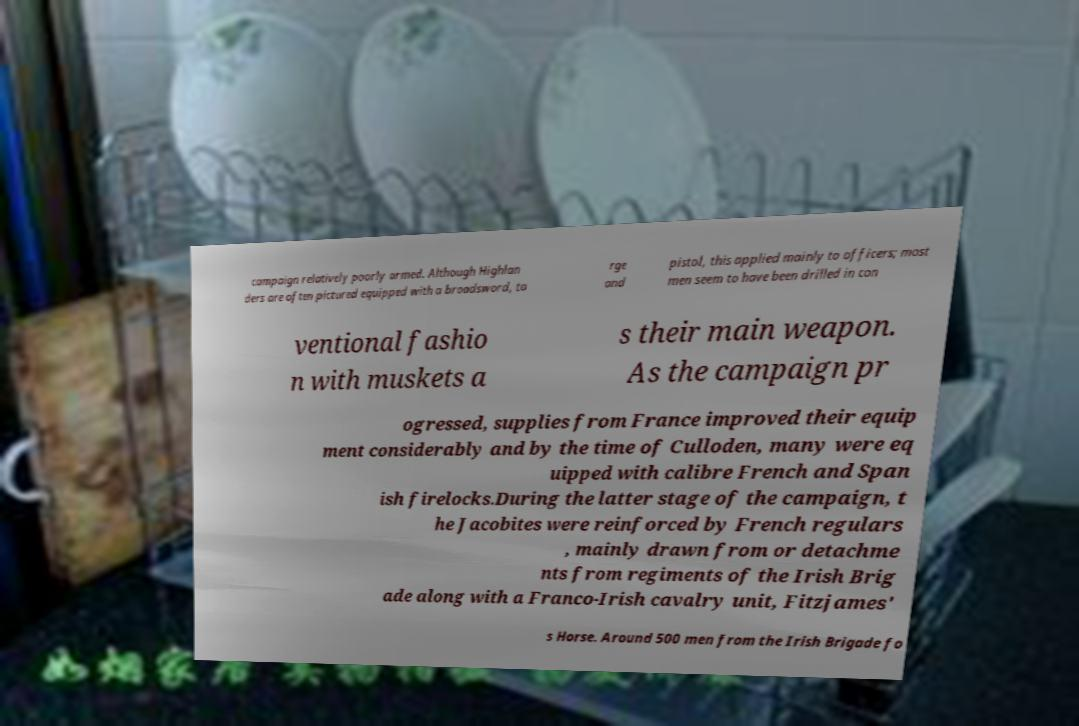Can you read and provide the text displayed in the image?This photo seems to have some interesting text. Can you extract and type it out for me? campaign relatively poorly armed. Although Highlan ders are often pictured equipped with a broadsword, ta rge and pistol, this applied mainly to officers; most men seem to have been drilled in con ventional fashio n with muskets a s their main weapon. As the campaign pr ogressed, supplies from France improved their equip ment considerably and by the time of Culloden, many were eq uipped with calibre French and Span ish firelocks.During the latter stage of the campaign, t he Jacobites were reinforced by French regulars , mainly drawn from or detachme nts from regiments of the Irish Brig ade along with a Franco-Irish cavalry unit, Fitzjames' s Horse. Around 500 men from the Irish Brigade fo 